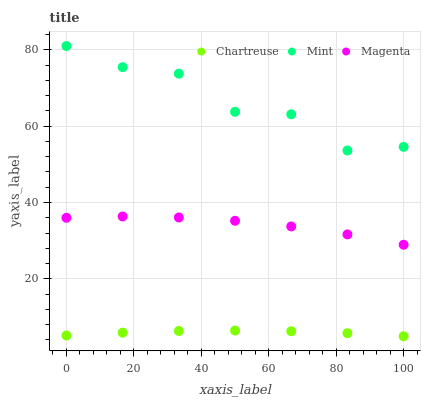Does Chartreuse have the minimum area under the curve?
Answer yes or no. Yes. Does Mint have the maximum area under the curve?
Answer yes or no. Yes. Does Magenta have the minimum area under the curve?
Answer yes or no. No. Does Magenta have the maximum area under the curve?
Answer yes or no. No. Is Chartreuse the smoothest?
Answer yes or no. Yes. Is Mint the roughest?
Answer yes or no. Yes. Is Magenta the smoothest?
Answer yes or no. No. Is Magenta the roughest?
Answer yes or no. No. Does Chartreuse have the lowest value?
Answer yes or no. Yes. Does Magenta have the lowest value?
Answer yes or no. No. Does Mint have the highest value?
Answer yes or no. Yes. Does Magenta have the highest value?
Answer yes or no. No. Is Chartreuse less than Mint?
Answer yes or no. Yes. Is Magenta greater than Chartreuse?
Answer yes or no. Yes. Does Chartreuse intersect Mint?
Answer yes or no. No. 